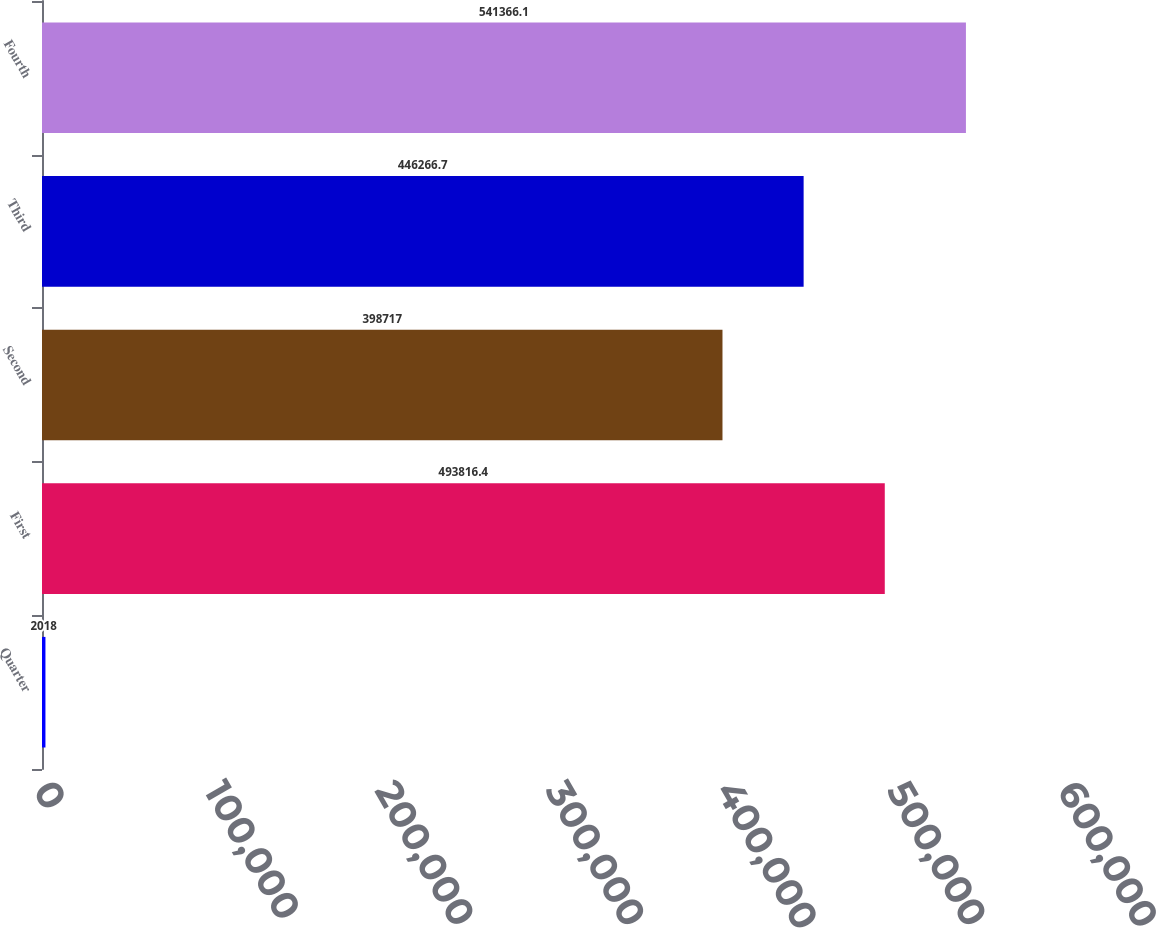Convert chart to OTSL. <chart><loc_0><loc_0><loc_500><loc_500><bar_chart><fcel>Quarter<fcel>First<fcel>Second<fcel>Third<fcel>Fourth<nl><fcel>2018<fcel>493816<fcel>398717<fcel>446267<fcel>541366<nl></chart> 